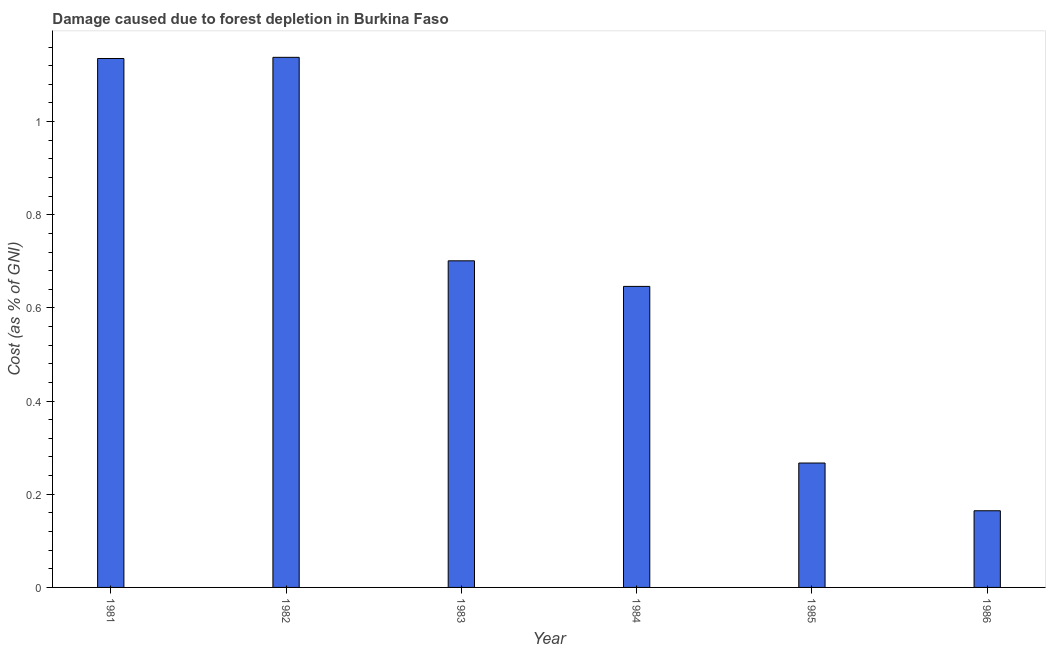Does the graph contain any zero values?
Your answer should be very brief. No. Does the graph contain grids?
Your answer should be compact. No. What is the title of the graph?
Your answer should be compact. Damage caused due to forest depletion in Burkina Faso. What is the label or title of the Y-axis?
Provide a short and direct response. Cost (as % of GNI). What is the damage caused due to forest depletion in 1981?
Make the answer very short. 1.14. Across all years, what is the maximum damage caused due to forest depletion?
Provide a short and direct response. 1.14. Across all years, what is the minimum damage caused due to forest depletion?
Give a very brief answer. 0.16. What is the sum of the damage caused due to forest depletion?
Offer a very short reply. 4.05. What is the difference between the damage caused due to forest depletion in 1982 and 1985?
Offer a terse response. 0.87. What is the average damage caused due to forest depletion per year?
Offer a very short reply. 0.68. What is the median damage caused due to forest depletion?
Ensure brevity in your answer.  0.67. Do a majority of the years between 1986 and 1982 (inclusive) have damage caused due to forest depletion greater than 0.64 %?
Provide a succinct answer. Yes. What is the ratio of the damage caused due to forest depletion in 1985 to that in 1986?
Keep it short and to the point. 1.62. What is the difference between the highest and the second highest damage caused due to forest depletion?
Your response must be concise. 0. Is the sum of the damage caused due to forest depletion in 1981 and 1983 greater than the maximum damage caused due to forest depletion across all years?
Your response must be concise. Yes. What is the difference between the highest and the lowest damage caused due to forest depletion?
Your answer should be very brief. 0.97. How many bars are there?
Give a very brief answer. 6. Are all the bars in the graph horizontal?
Offer a terse response. No. How many years are there in the graph?
Your response must be concise. 6. Are the values on the major ticks of Y-axis written in scientific E-notation?
Provide a short and direct response. No. What is the Cost (as % of GNI) of 1981?
Your answer should be very brief. 1.14. What is the Cost (as % of GNI) of 1982?
Offer a very short reply. 1.14. What is the Cost (as % of GNI) in 1983?
Make the answer very short. 0.7. What is the Cost (as % of GNI) of 1984?
Provide a short and direct response. 0.65. What is the Cost (as % of GNI) of 1985?
Your response must be concise. 0.27. What is the Cost (as % of GNI) of 1986?
Your answer should be compact. 0.16. What is the difference between the Cost (as % of GNI) in 1981 and 1982?
Offer a terse response. -0. What is the difference between the Cost (as % of GNI) in 1981 and 1983?
Offer a very short reply. 0.43. What is the difference between the Cost (as % of GNI) in 1981 and 1984?
Provide a short and direct response. 0.49. What is the difference between the Cost (as % of GNI) in 1981 and 1985?
Keep it short and to the point. 0.87. What is the difference between the Cost (as % of GNI) in 1981 and 1986?
Keep it short and to the point. 0.97. What is the difference between the Cost (as % of GNI) in 1982 and 1983?
Provide a succinct answer. 0.44. What is the difference between the Cost (as % of GNI) in 1982 and 1984?
Keep it short and to the point. 0.49. What is the difference between the Cost (as % of GNI) in 1982 and 1985?
Offer a very short reply. 0.87. What is the difference between the Cost (as % of GNI) in 1982 and 1986?
Your answer should be compact. 0.97. What is the difference between the Cost (as % of GNI) in 1983 and 1984?
Ensure brevity in your answer.  0.05. What is the difference between the Cost (as % of GNI) in 1983 and 1985?
Keep it short and to the point. 0.43. What is the difference between the Cost (as % of GNI) in 1983 and 1986?
Your answer should be very brief. 0.54. What is the difference between the Cost (as % of GNI) in 1984 and 1985?
Give a very brief answer. 0.38. What is the difference between the Cost (as % of GNI) in 1984 and 1986?
Your answer should be very brief. 0.48. What is the difference between the Cost (as % of GNI) in 1985 and 1986?
Keep it short and to the point. 0.1. What is the ratio of the Cost (as % of GNI) in 1981 to that in 1983?
Your answer should be very brief. 1.62. What is the ratio of the Cost (as % of GNI) in 1981 to that in 1984?
Make the answer very short. 1.76. What is the ratio of the Cost (as % of GNI) in 1981 to that in 1985?
Provide a short and direct response. 4.25. What is the ratio of the Cost (as % of GNI) in 1981 to that in 1986?
Your response must be concise. 6.9. What is the ratio of the Cost (as % of GNI) in 1982 to that in 1983?
Offer a very short reply. 1.62. What is the ratio of the Cost (as % of GNI) in 1982 to that in 1984?
Your answer should be very brief. 1.76. What is the ratio of the Cost (as % of GNI) in 1982 to that in 1985?
Keep it short and to the point. 4.26. What is the ratio of the Cost (as % of GNI) in 1982 to that in 1986?
Give a very brief answer. 6.91. What is the ratio of the Cost (as % of GNI) in 1983 to that in 1984?
Give a very brief answer. 1.08. What is the ratio of the Cost (as % of GNI) in 1983 to that in 1985?
Your response must be concise. 2.62. What is the ratio of the Cost (as % of GNI) in 1983 to that in 1986?
Ensure brevity in your answer.  4.26. What is the ratio of the Cost (as % of GNI) in 1984 to that in 1985?
Offer a terse response. 2.42. What is the ratio of the Cost (as % of GNI) in 1984 to that in 1986?
Your answer should be compact. 3.93. What is the ratio of the Cost (as % of GNI) in 1985 to that in 1986?
Offer a very short reply. 1.62. 